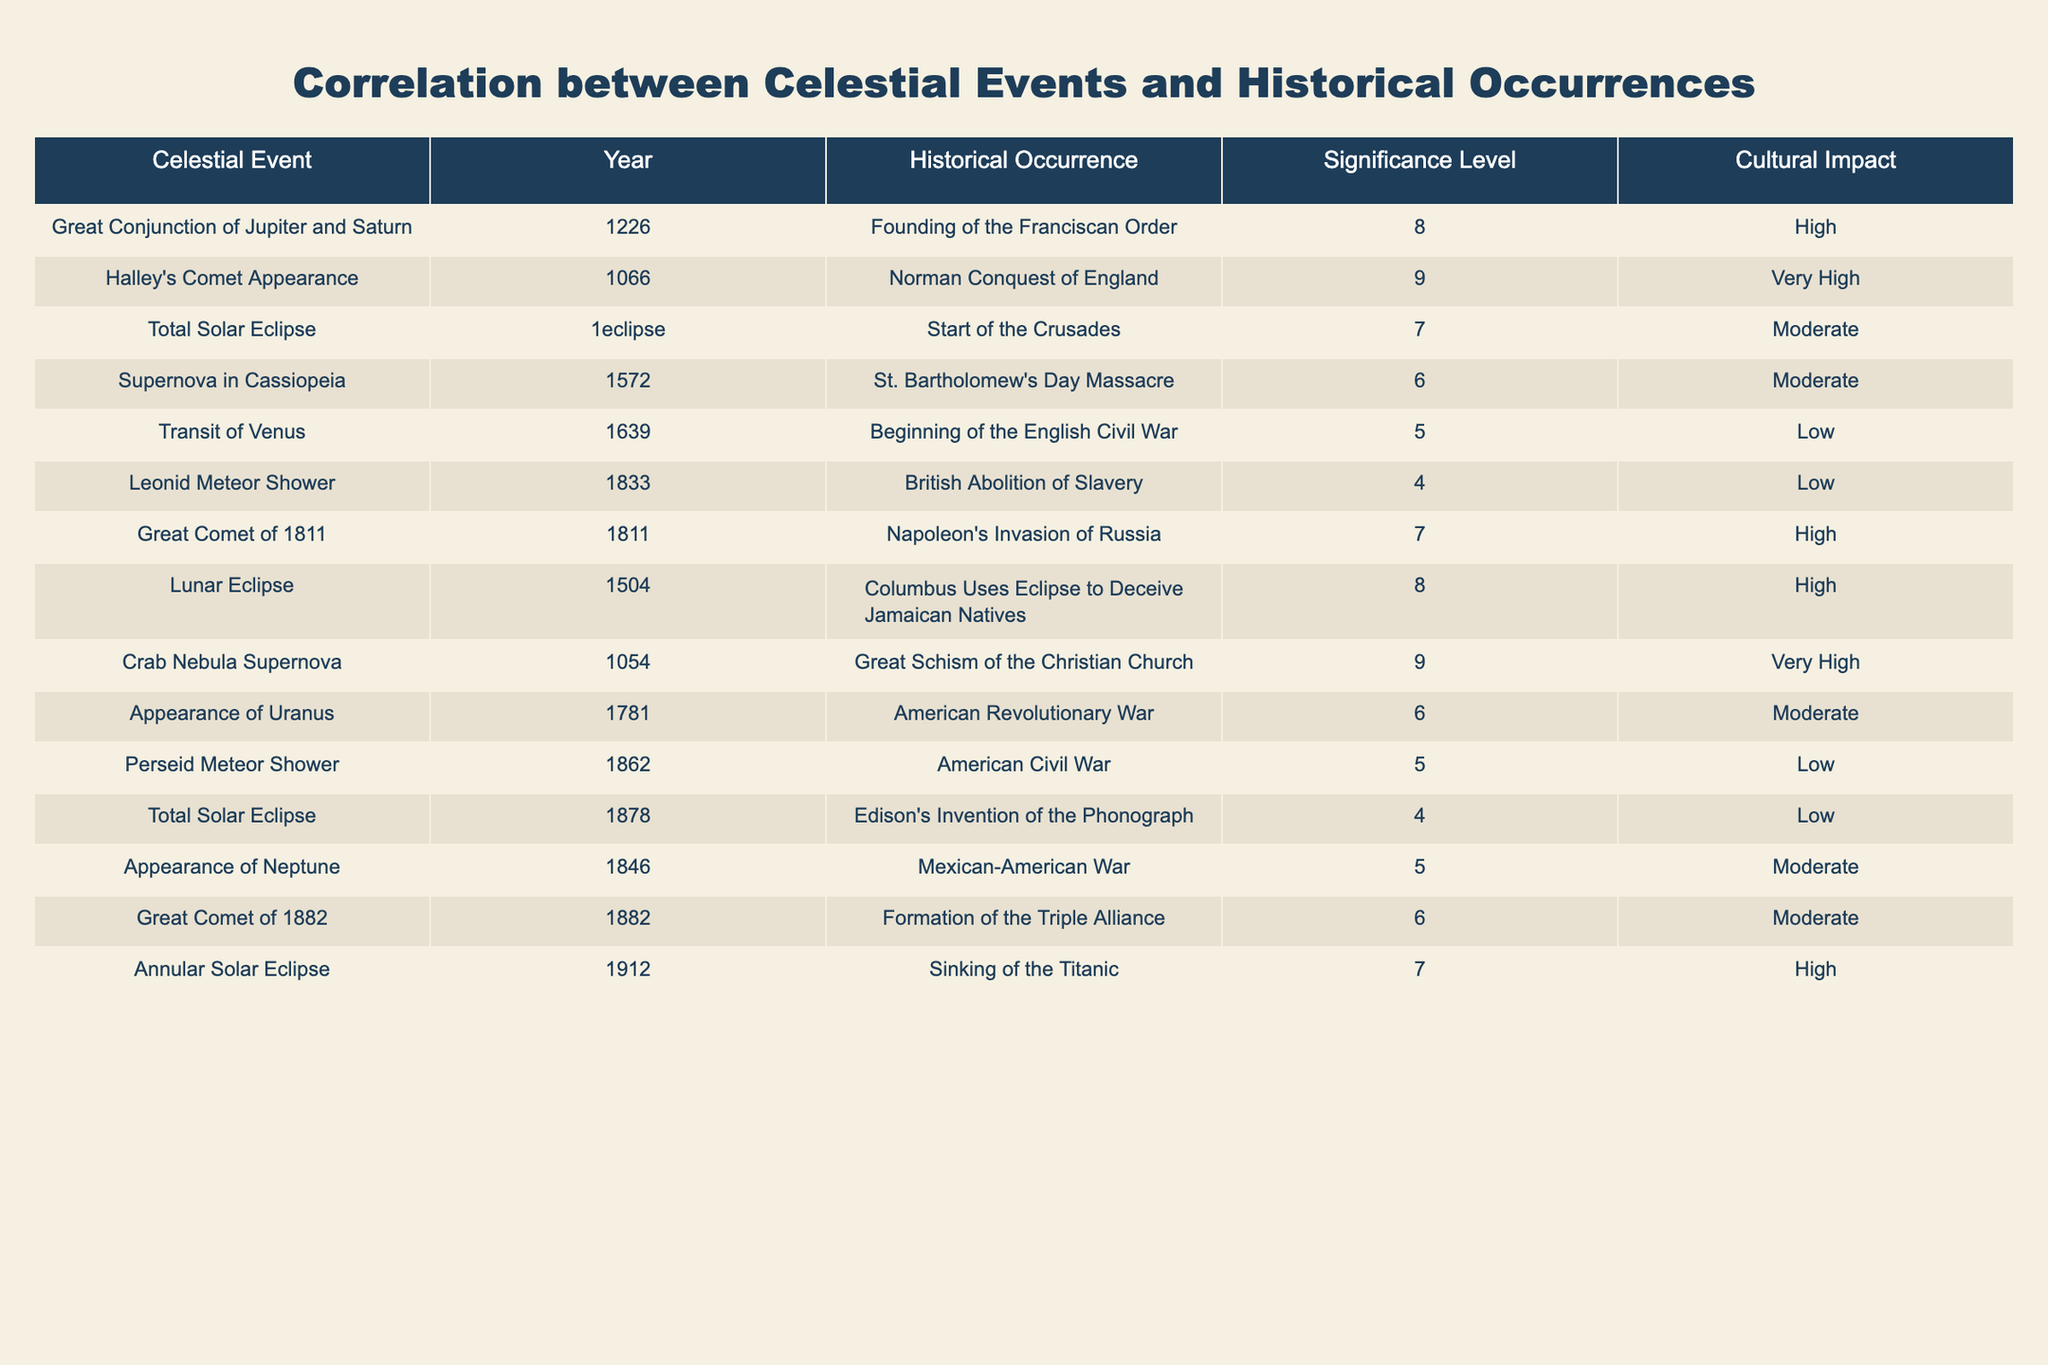What was the significance level of the Great Conjunction of Jupiter and Saturn? The significance level for the Great Conjunction of Jupiter and Saturn is listed in the table under the "Significance Level" column, which shows the value as 8.
Answer: 8 Which celestial event is associated with the Norman Conquest of England? The table contains a row for the Norman Conquest of England, which is linked to the appearance of Halley's Comet listed in the "Celestial Event" column.
Answer: Halley's Comet Appearance What is the average significance level of the celestial events listed in the table? To calculate the average significance level, add all significance levels (8 + 9 + 7 + 6 + 5 + 4 + 7 + 8 + 9 + 6 + 5 + 4 + 5 + 6 + 7) equaling 8, divide by the number of events (15), so the average significance level is approximately 6.33.
Answer: 6.33 Has a total solar eclipse occurred in years associated with significant historical events? There are two instances of total solar eclipses listed (the one in the year 1 and the one in 1878), both associated with historical events. Thus, this statement is true.
Answer: Yes What celestial event has the highest historical impact? The table indicates that Halley's Comet Appearance has the highest cultural impact labeled as "Very High."
Answer: Halley's Comet Appearance How many events had a "High" cultural impact? By examining the "Cultural Impact" column, occurrences with a "High" label include the Great Comet of 1811, Lunar Eclipse in 1504, and Annular Solar Eclipse in 1912. This totals to three events.
Answer: 3 Was there any correlation between celestial events having a significance level of 9 and their historical occurrences? In the table, both Halley's Comet Appearance and the Crab Nebula Supernova have a significance level of 9. They correspond to major events in history, which suggests a correlation between high significance levels and historical significance.
Answer: Yes What is the difference in significance levels between the most significant event and the least significant one? The most significant event has a level of 9 (Halley's Comet) and the least significant one has a level of 4 (Total Solar Eclipse in 1878). The difference is 9 - 4 = 5.
Answer: 5 Which event occurred first, Columbus using an eclipse or the Great Conjunction of Jupiter and Saturn? By comparing the years listed, the Great Conjunction of Jupiter and Saturn occurred in 1226, while Columbus used an eclipse in 1504, indicating the Great Conjunction occurred earlier.
Answer: Great Conjunction of Jupiter and Saturn How many celestial events resulted in significant cultural impacts labeled as "Moderate"? The table includes the following events marked as "Moderate": Supernova in Cassiopeia, Appearance of Neptune, Great Comet of 1882, and Total Solar Eclipse in 1878. Each event indicates a total of four events labeled as "Moderate."
Answer: 4 